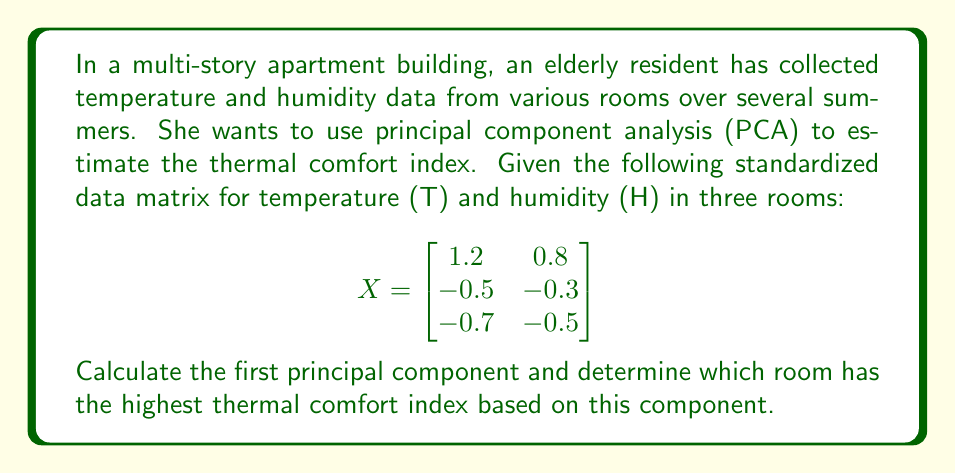Show me your answer to this math problem. To solve this problem, we'll follow these steps:

1) Calculate the covariance matrix:
   $$C = \frac{1}{n-1}X^TX$$
   where n is the number of rooms (3).

   $$C = \frac{1}{2}\begin{bmatrix}
   1.2 & -0.5 & -0.7 \\
   0.8 & -0.3 & -0.5
   \end{bmatrix}\begin{bmatrix}
   1.2 & 0.8 \\
   -0.5 & -0.3 \\
   -0.7 & -0.5
   \end{bmatrix}$$

   $$C = \frac{1}{2}\begin{bmatrix}
   2.98 & 2.06 \\
   2.06 & 1.42
   \end{bmatrix}$$

2) Find eigenvalues and eigenvectors of C:
   Characteristic equation: $\det(C - \lambda I) = 0$
   
   $$\begin{vmatrix}
   1.49 - \lambda & 1.03 \\
   1.03 & 0.71 - \lambda
   \end{vmatrix} = 0$$

   $$(1.49 - \lambda)(0.71 - \lambda) - 1.03^2 = 0$$
   
   $\lambda^2 - 2.2\lambda + 0.0013 = 0$

   Solving this quadratic equation gives:
   $\lambda_1 \approx 2.1987$ and $\lambda_2 \approx 0.0013$

3) The eigenvector corresponding to $\lambda_1$ is the first principal component:
   $$(C - \lambda_1 I)v = 0$$
   
   Solving this gives the normalized eigenvector:
   $$v_1 \approx \begin{bmatrix}
   0.7071 \\
   0.7071
   \end{bmatrix}$$

4) Project the data onto the first principal component:
   $$Y = Xv_1$$

   $$Y = \begin{bmatrix}
   1.2 & 0.8 \\
   -0.5 & -0.3 \\
   -0.7 & -0.5
   \end{bmatrix}\begin{bmatrix}
   0.7071 \\
   0.7071
   \end{bmatrix}$$

   $$Y \approx \begin{bmatrix}
   1.4142 \\
   -0.5657 \\
   -0.8485
   \end{bmatrix}$$

5) The highest value in Y corresponds to the room with the highest thermal comfort index based on the first principal component.
Answer: Room 1 (Y ≈ 1.4142) 